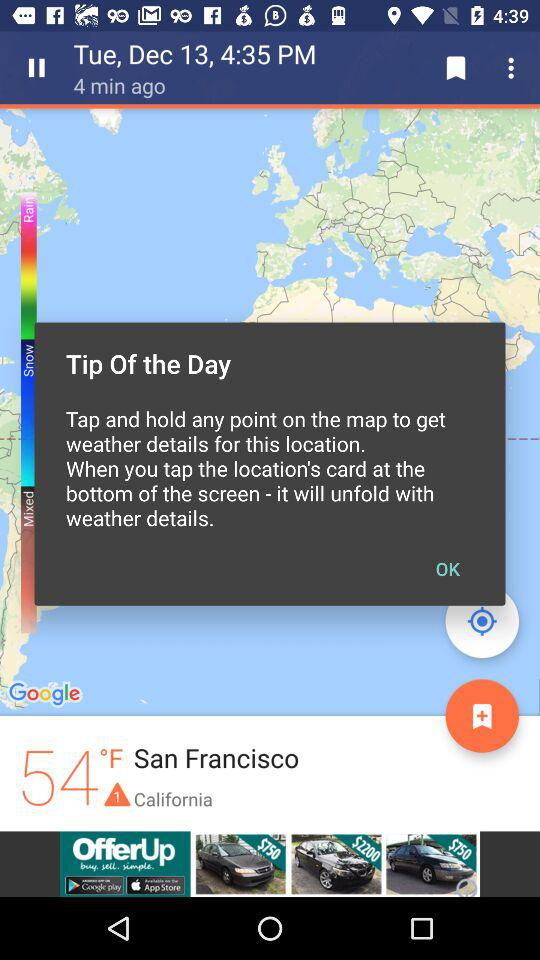How many degrees Fahrenheit is the temperature in San Francisco?
Answer the question using a single word or phrase. 54°F 